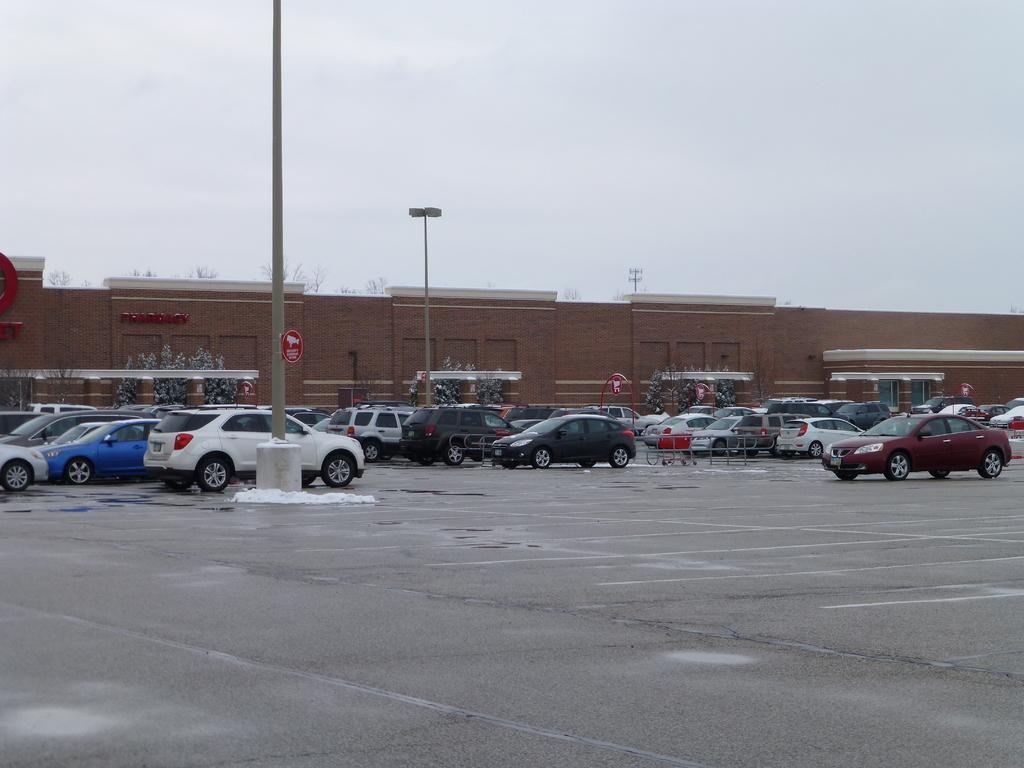Could you give a brief overview of what you see in this image? In this image, we can see so many vehicles are parked on the road. There are few signboards, poles, trees, wall we can see. Background we can see the sky. 